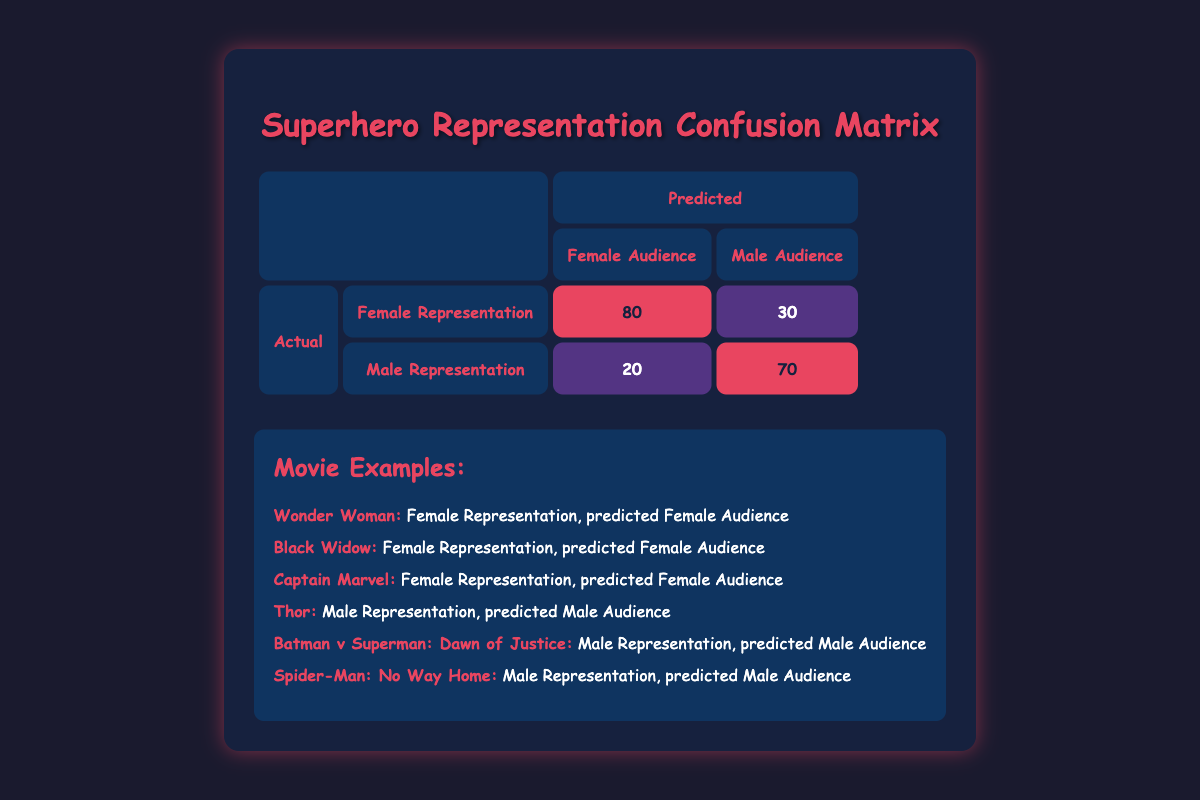What is the total number of individuals represented in the Female Audience category? In the Female Audience category, the values are 80 (Female Representation) and 30 (Male Representation). Adding these together: 80 + 30 = 110.
Answer: 110 What percentage of the Male Audience predicted a Male Representation? The value for Male Representation in the Male Audience category is 70. To find the percentage, we take the value (70) and divide it by the total for Male Audience which is 70 + 30 = 100. Therefore, 70/100 * 100% = 70%.
Answer: 70% Is there more Female Representation predicted for the Female Audience than for the Male Audience? The values for Female Representation are 80 (Female Audience) and 20 (Male Audience). Since 80 is greater than 20, the answer is yes.
Answer: Yes What is the difference in representation between Female Representation in the Female Audience and Male Representation in the Male Audience? For Female Representation in the Female Audience, the value is 80, and for Male Representation in the Male Audience, the value is 70. To find the difference, we subtract: 80 - 70 = 10.
Answer: 10 Which movie titles are associated with Female Representation being predicted for a Female Audience? The movies listed under Female Representation and predicted Female Audience in the table are "Wonder Woman," "Black Widow," and "Captain Marvel."
Answer: Wonder Woman, Black Widow, Captain Marvel What is the proportion of Male Representation that predicted a Female Audience? The Male Representation predicted a Female Audience is 20. The total number of individuals represented in this row is 20 (from Female Audience) + 70 (from Male Audience) = 90. Therefore, the proportion is 20/90 = 0.22, or approximately 22%.
Answer: 22% Are there more female characters represented in superhero movies compared to male characters when looking at the predicted Female Audience? Yes, the table shows 80 for Female Representation in the Female Audience and 30 for Male Representation in the Female Audience, indicating more female characters are represented.
Answer: Yes If we sum the predicted Female Audience and Male Audience, what total do we get? The predicted values for Female Audience is 80 and for Male Audience is 30. Summing these together gives us 80 + 30 = 110.
Answer: 110 